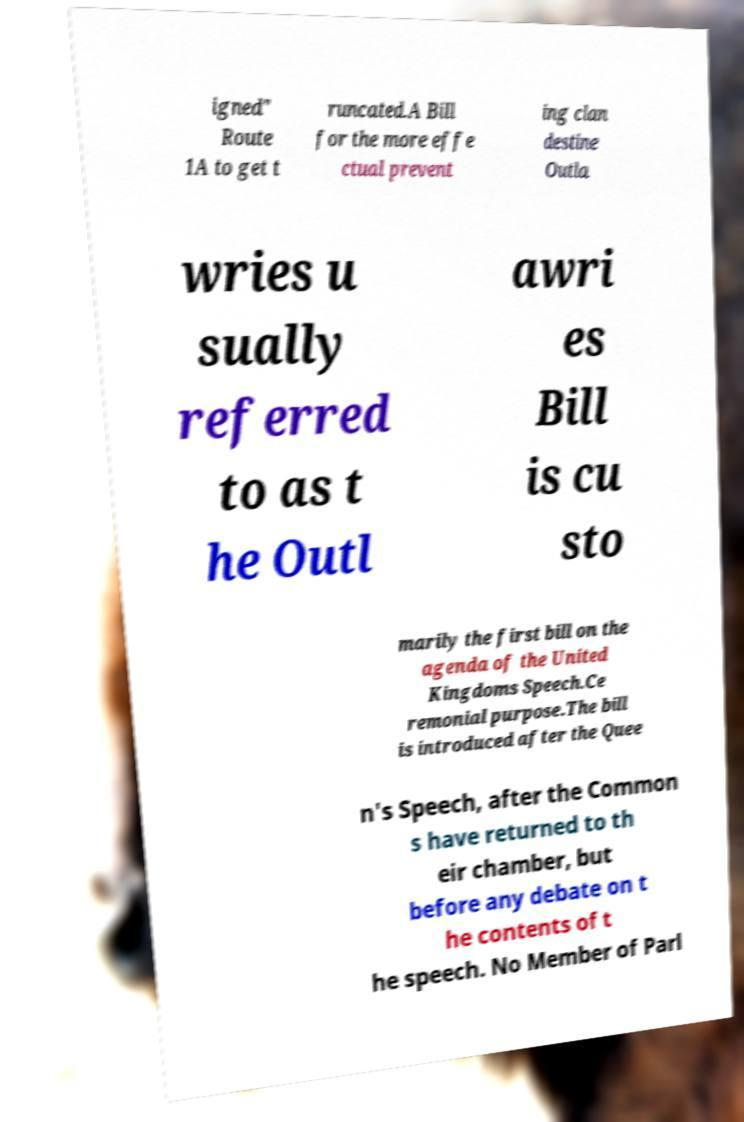What messages or text are displayed in this image? I need them in a readable, typed format. igned" Route 1A to get t runcated.A Bill for the more effe ctual prevent ing clan destine Outla wries u sually referred to as t he Outl awri es Bill is cu sto marily the first bill on the agenda of the United Kingdoms Speech.Ce remonial purpose.The bill is introduced after the Quee n's Speech, after the Common s have returned to th eir chamber, but before any debate on t he contents of t he speech. No Member of Parl 